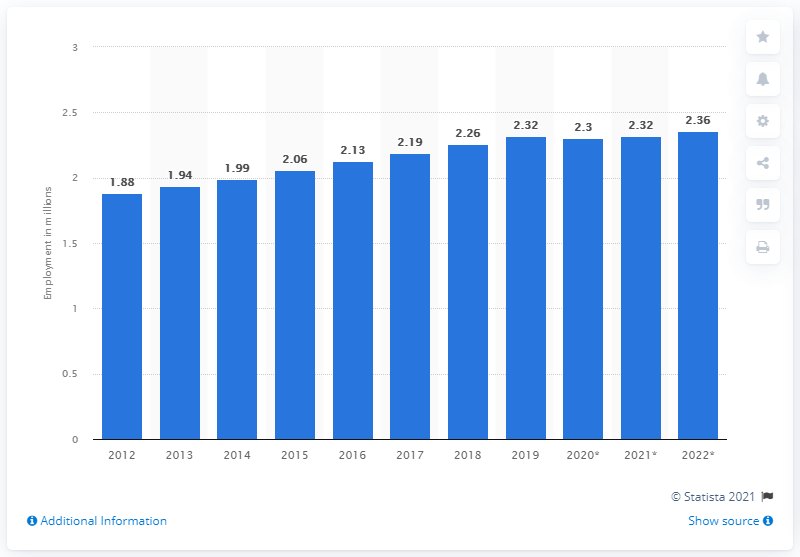Indicate a few pertinent items in this graphic. In 2019, the number of people employed in Ireland was 2.32 million. 